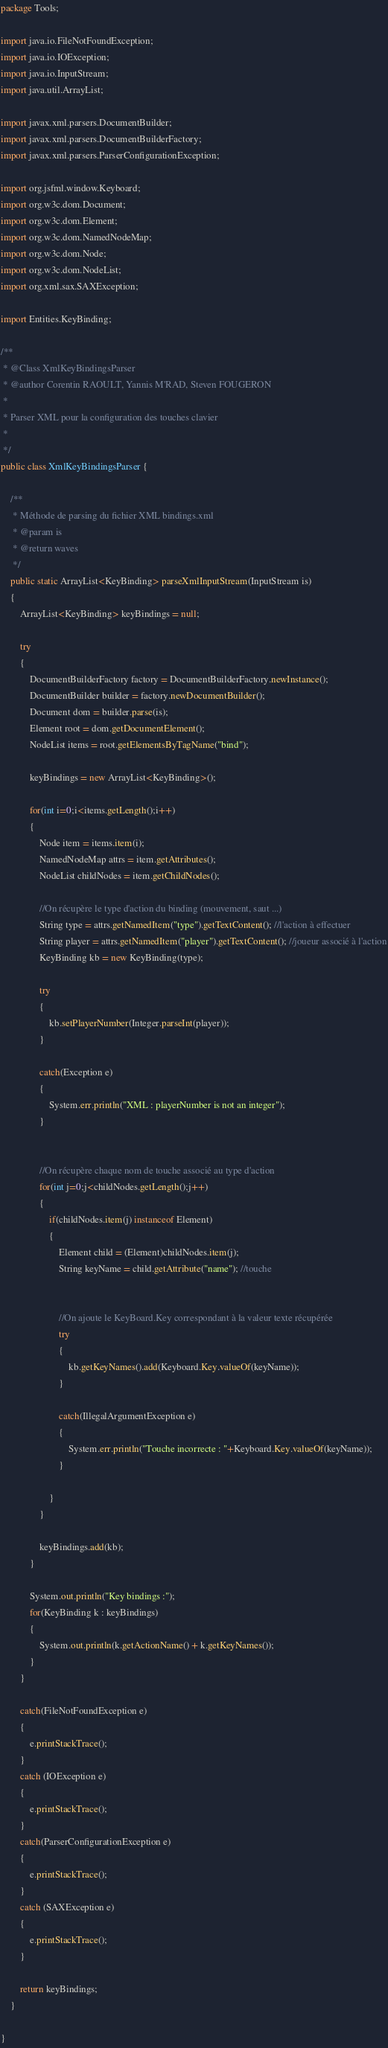<code> <loc_0><loc_0><loc_500><loc_500><_Java_>package Tools;

import java.io.FileNotFoundException;
import java.io.IOException;
import java.io.InputStream;
import java.util.ArrayList;

import javax.xml.parsers.DocumentBuilder;
import javax.xml.parsers.DocumentBuilderFactory;
import javax.xml.parsers.ParserConfigurationException;

import org.jsfml.window.Keyboard;
import org.w3c.dom.Document;
import org.w3c.dom.Element;
import org.w3c.dom.NamedNodeMap;
import org.w3c.dom.Node;
import org.w3c.dom.NodeList;
import org.xml.sax.SAXException;

import Entities.KeyBinding;

/**
 * @Class XmlKeyBindingsParser
 * @author Corentin RAOULT, Yannis M'RAD, Steven FOUGERON
 * 
 * Parser XML pour la configuration des touches clavier
 *
 */
public class XmlKeyBindingsParser {
	
	/**
	 * Méthode de parsing du fichier XML bindings.xml
	 * @param is
	 * @return waves
	 */
	public static ArrayList<KeyBinding> parseXmlInputStream(InputStream is)
	{
		ArrayList<KeyBinding> keyBindings = null;
		
		try
		{
			DocumentBuilderFactory factory = DocumentBuilderFactory.newInstance();
			DocumentBuilder builder = factory.newDocumentBuilder();	
			Document dom = builder.parse(is);
			Element root = dom.getDocumentElement();
			NodeList items = root.getElementsByTagName("bind");
			
			keyBindings = new ArrayList<KeyBinding>();
			
			for(int i=0;i<items.getLength();i++)
			{
				Node item = items.item(i);
				NamedNodeMap attrs = item.getAttributes();
				NodeList childNodes = item.getChildNodes();
				
				//On récupère le type d'action du binding (mouvement, saut ...)
				String type = attrs.getNamedItem("type").getTextContent(); //l'action à effectuer
				String player = attrs.getNamedItem("player").getTextContent(); //joueur associé à l'action
				KeyBinding kb = new KeyBinding(type);
				
				try
				{
					kb.setPlayerNumber(Integer.parseInt(player));
				}
				
				catch(Exception e)
				{
					System.err.println("XML : playerNumber is not an integer");
				}
				
				
				//On récupère chaque nom de touche associé au type d'action
				for(int j=0;j<childNodes.getLength();j++)
				{
					if(childNodes.item(j) instanceof Element)
					{
						Element child = (Element)childNodes.item(j);
						String keyName = child.getAttribute("name"); //touche
						
						
						//On ajoute le KeyBoard.Key correspondant à la valeur texte récupérée
						try
						{
							kb.getKeyNames().add(Keyboard.Key.valueOf(keyName));
						}
						
						catch(IllegalArgumentException e)
						{
							System.err.println("Touche incorrecte : "+Keyboard.Key.valueOf(keyName));
						}
						
					}	
				}
				
				keyBindings.add(kb);
			}
			
			System.out.println("Key bindings :");
			for(KeyBinding k : keyBindings)
			{
				System.out.println(k.getActionName() + k.getKeyNames());
			}
		}
		
		catch(FileNotFoundException e)
		{
			e.printStackTrace();
		}
		catch (IOException e) 
		{
			e.printStackTrace();
		}
		catch(ParserConfigurationException e)
		{
			e.printStackTrace();
		}
		catch (SAXException e) 
		{
			e.printStackTrace();
		}
		
		return keyBindings;
	}

}
</code> 